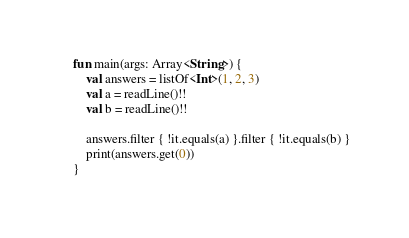<code> <loc_0><loc_0><loc_500><loc_500><_Kotlin_>fun main(args: Array<String>) {
    val answers = listOf<Int>(1, 2, 3)
    val a = readLine()!!
    val b = readLine()!!

    answers.filter { !it.equals(a) }.filter { !it.equals(b) }
    print(answers.get(0))
}</code> 